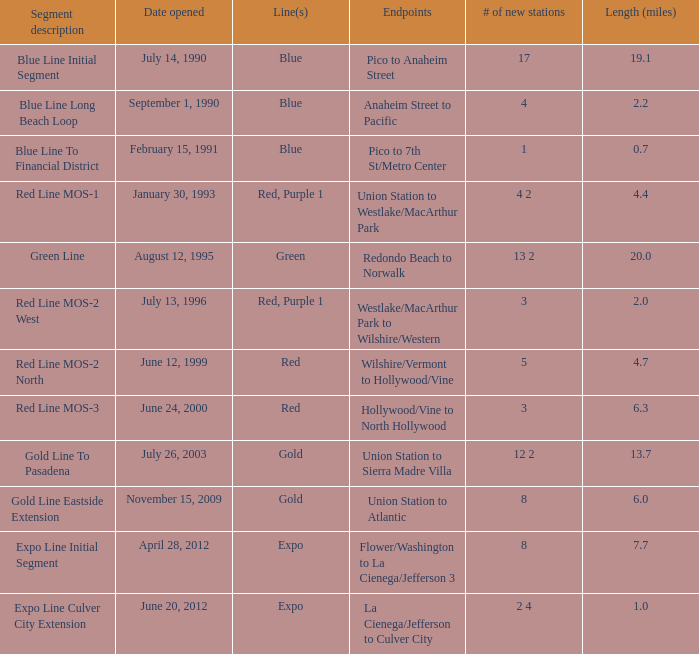What date of segment description red line mos-2 north open? June 12, 1999. 